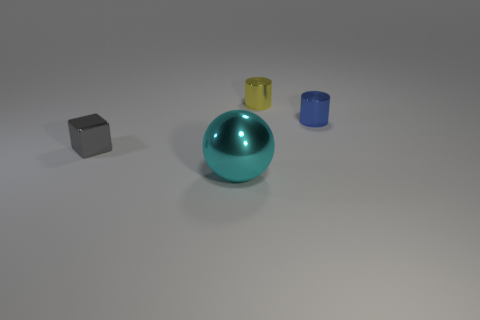What number of gray objects are either tiny shiny cylinders or objects?
Your answer should be very brief. 1. The blue thing that is the same size as the gray metallic thing is what shape?
Make the answer very short. Cylinder. There is a ball in front of the small cylinder on the right side of the yellow thing; what is its size?
Give a very brief answer. Large. Are the object in front of the small metal cube and the small blue thing made of the same material?
Offer a very short reply. Yes. There is a thing to the left of the big cyan metallic object; what shape is it?
Your answer should be compact. Cube. What number of gray cubes have the same size as the cyan metal thing?
Make the answer very short. 0. What is the size of the yellow thing?
Give a very brief answer. Small. How many big cyan metallic things are in front of the large cyan object?
Your answer should be very brief. 0. There is a cyan object that is made of the same material as the tiny gray object; what shape is it?
Provide a succinct answer. Sphere. Are there fewer shiny blocks that are behind the blue cylinder than yellow cylinders in front of the tiny shiny cube?
Your response must be concise. No. 